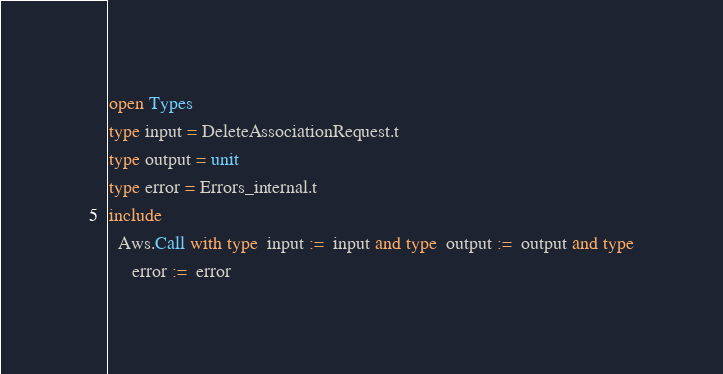<code> <loc_0><loc_0><loc_500><loc_500><_OCaml_>open Types
type input = DeleteAssociationRequest.t
type output = unit
type error = Errors_internal.t
include
  Aws.Call with type  input :=  input and type  output :=  output and type
     error :=  error</code> 